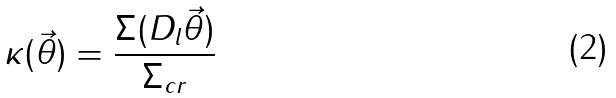<formula> <loc_0><loc_0><loc_500><loc_500>\kappa ( \vec { \theta } ) = \frac { \Sigma ( D _ { l } \vec { \theta } ) } { \Sigma _ { c r } }</formula> 